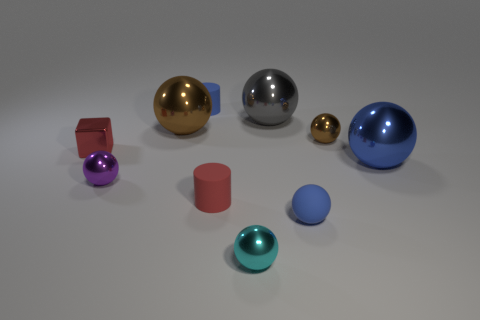The red metal block has what size?
Keep it short and to the point. Small. What number of cyan things are either metal blocks or large matte cylinders?
Provide a succinct answer. 0. How many big brown shiny things have the same shape as the small brown metal thing?
Your response must be concise. 1. What number of cubes have the same size as the blue matte cylinder?
Keep it short and to the point. 1. What material is the big gray thing that is the same shape as the big brown thing?
Give a very brief answer. Metal. What color is the small rubber cylinder that is left of the red rubber object?
Offer a terse response. Blue. Is the number of cubes on the right side of the blue matte sphere greater than the number of green metallic cubes?
Your answer should be very brief. No. The tiny matte sphere is what color?
Your answer should be very brief. Blue. What shape is the blue rubber object in front of the small matte thing behind the shiny sphere that is on the right side of the small brown metallic sphere?
Give a very brief answer. Sphere. What is the material of the tiny thing that is in front of the big blue metallic ball and to the left of the large brown shiny object?
Provide a short and direct response. Metal. 